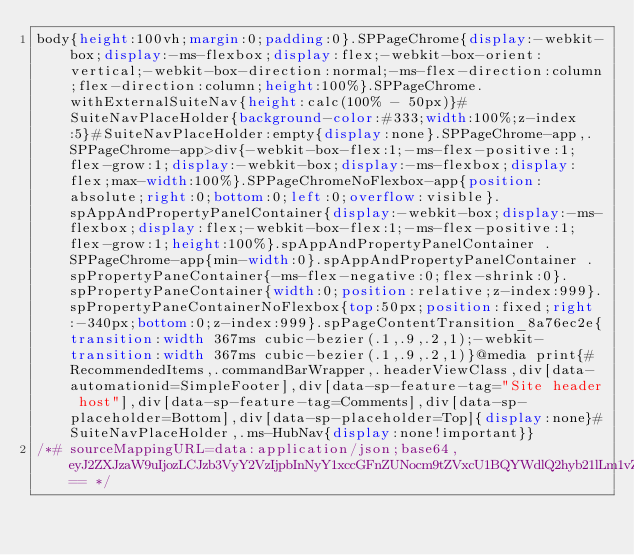<code> <loc_0><loc_0><loc_500><loc_500><_CSS_>body{height:100vh;margin:0;padding:0}.SPPageChrome{display:-webkit-box;display:-ms-flexbox;display:flex;-webkit-box-orient:vertical;-webkit-box-direction:normal;-ms-flex-direction:column;flex-direction:column;height:100%}.SPPageChrome.withExternalSuiteNav{height:calc(100% - 50px)}#SuiteNavPlaceHolder{background-color:#333;width:100%;z-index:5}#SuiteNavPlaceHolder:empty{display:none}.SPPageChrome-app,.SPPageChrome-app>div{-webkit-box-flex:1;-ms-flex-positive:1;flex-grow:1;display:-webkit-box;display:-ms-flexbox;display:flex;max-width:100%}.SPPageChromeNoFlexbox-app{position:absolute;right:0;bottom:0;left:0;overflow:visible}.spAppAndPropertyPanelContainer{display:-webkit-box;display:-ms-flexbox;display:flex;-webkit-box-flex:1;-ms-flex-positive:1;flex-grow:1;height:100%}.spAppAndPropertyPanelContainer .SPPageChrome-app{min-width:0}.spAppAndPropertyPanelContainer .spPropertyPaneContainer{-ms-flex-negative:0;flex-shrink:0}.spPropertyPaneContainer{width:0;position:relative;z-index:999}.spPropertyPaneContainerNoFlexbox{top:50px;position:fixed;right:-340px;bottom:0;z-index:999}.spPageContentTransition_8a76ec2e{transition:width 367ms cubic-bezier(.1,.9,.2,1);-webkit-transition:width 367ms cubic-bezier(.1,.9,.2,1)}@media print{#RecommendedItems,.commandBarWrapper,.headerViewClass,div[data-automationid=SimpleFooter],div[data-sp-feature-tag="Site header host"],div[data-sp-feature-tag=Comments],div[data-sp-placeholder=Bottom],div[data-sp-placeholder=Top]{display:none}#SuiteNavPlaceHolder,.ms-HubNav{display:none!important}}
/*# sourceMappingURL=data:application/json;base64,eyJ2ZXJzaW9uIjozLCJzb3VyY2VzIjpbInNyY1xccGFnZUNocm9tZVxcU1BQYWdlQ2hyb21lLm1vZHVsZS5zY3NzIl0sIm5hbWVzIjpbXSwibWFwcGluZ3MiOiJBQU1BLEtBQ0UsT0FBQSxNQUNBLE9BQUEsRUFDQSxRQUFBLEVBR0YsY0FDRSxRQUFBLFlBQUEsUUFBQSxZQUFBLFFBQUEsS0FDQSxtQkFBQSxTQUFBLHNCQUFBLE9BQUEsbUJBQUEsT0FBQSxlQUFBLE9BQ0EsT0FBQSxLQUdGLG1DQUNJLE9BQUEsa0JBR0oscUJBQ0UsaUJBQUEsS0FDQSxNQUFBLEtBQ0EsUUFBQSxFQUhGLDJCQU1JLFFBQUEsS0FRSixrQkFBQSxzQkFDRSxpQkFBQSxFQUFBLGtCQUFBLEVBQUEsVUFBQSxFQUNBLFFBQUEsWUFBQSxRQUFBLFlBQUEsUUFBQSxLQUNBLFVBQUEsS0FHRiwyQkFDRSxTQUFBLFNBQ0EsTUFBQSxFQUNBLE9BQUEsRUFDQSxLQUFBLEVBQ0EsU0FBQSxRQUdGLGdDQUNFLFFBQUEsWUFBQSxRQUFBLFlBQUEsUUFBQSxLQUNBLGlCQUFBLEVBQUEsa0JBQUEsRUFBQSxVQUFBLEVBQ0EsT0FBQSxLQUhGLGtEQUtJLFVBQUEsRUFMSix5REFRSSxrQkFBQSxFQUFBLFlBQUEsRUFLSix5QkFDRSxNQUFBLEVBQ0EsU0FBQSxTQUNBLFFBQUEsSUFJRixrQ0FJRSxJQUFBLEtBQ0EsU0FBQSxNQUNBLE1BQUEsT0FDQSxPQUFBLEVBQ0EsUUFBQSxJQUlGLGtDQUNFLFdBQUEsTUFBQSxNQUFBLHlCQUNBLG1CQUFBLE1BQUEsTUFBQSx5QkFJQSxhQURGLGtCQUFBLG1CQUFBLGlCQUFBLG9DQUFBLDRDQUFBLGtDQUFBLGdDQUFBLDZCQVVNLFFBQUEsS0FWTixxQkFBQSxXQWNNLFFBQUEifQ== */</code> 